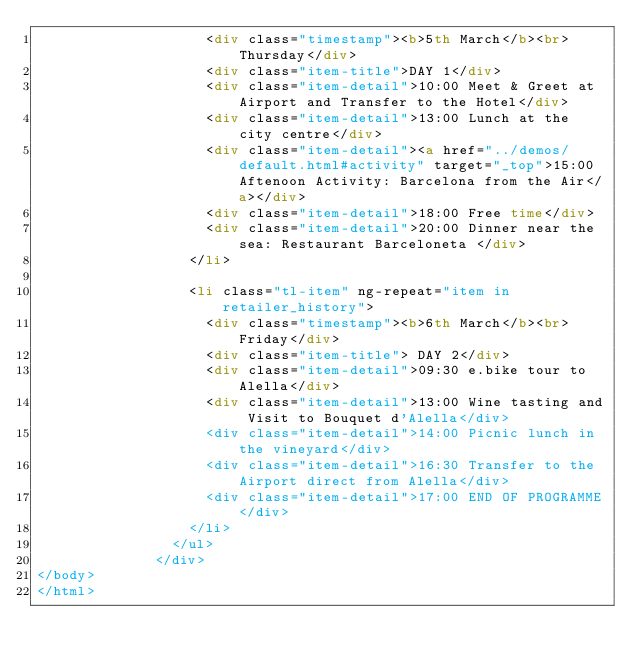<code> <loc_0><loc_0><loc_500><loc_500><_HTML_>                    <div class="timestamp"><b>5th March</b><br>Thursday</div>
                    <div class="item-title">DAY 1</div>
                    <div class="item-detail">10:00 Meet & Greet at Airport and Transfer to the Hotel</div>
                    <div class="item-detail">13:00 Lunch at the city centre</div>
                    <div class="item-detail"><a href="../demos/default.html#activity" target="_top">15:00 Aftenoon Activity: Barcelona from the Air</a></div>
					<div class="item-detail">18:00 Free time</div>
					<div class="item-detail">20:00 Dinner near the sea: Restaurant Barceloneta </div>
                  </li>

                  <li class="tl-item" ng-repeat="item in retailer_history">
                    <div class="timestamp"><b>6th March</b><br> Friday</div>
                    <div class="item-title"> DAY 2</div>
                    <div class="item-detail">09:30 e.bike tour to Alella</div>
					<div class="item-detail">13:00 Wine tasting and Visit to Bouquet d'Alella</div>
					<div class="item-detail">14:00 Picnic lunch in the vineyard</div>
					<div class="item-detail">16:30 Transfer to the Airport direct from Alella</div>
					<div class="item-detail">17:00 END OF PROGRAMME</div>
                  </li>
                </ul>              
              </div>
</body>
</html></code> 